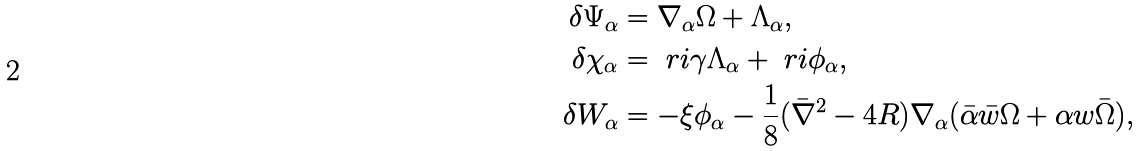<formula> <loc_0><loc_0><loc_500><loc_500>\delta \Psi _ { \alpha } & = \nabla _ { \alpha } \Omega + \Lambda _ { \alpha } , \\ \delta \chi _ { \alpha } & = \ r i \gamma \Lambda _ { \alpha } + \ r i \phi _ { \alpha } , \\ \delta W _ { \alpha } & = - \xi \phi _ { \alpha } - \frac { 1 } { 8 } ( \bar { \nabla } ^ { 2 } - 4 R ) \nabla _ { \alpha } ( \bar { \alpha } \bar { w } \Omega + \alpha w \bar { \Omega } ) ,</formula> 